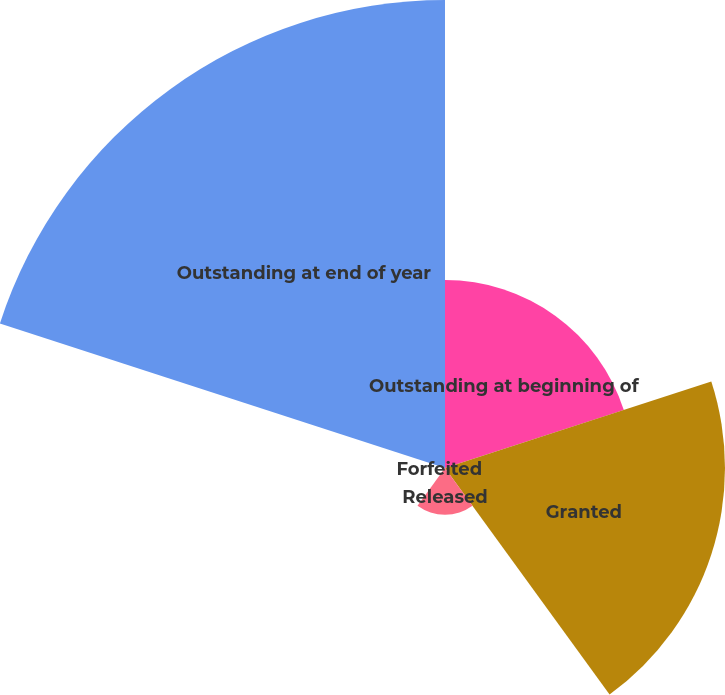Convert chart to OTSL. <chart><loc_0><loc_0><loc_500><loc_500><pie_chart><fcel>Outstanding at beginning of<fcel>Granted<fcel>Released<fcel>Forfeited<fcel>Outstanding at end of year<nl><fcel>19.13%<fcel>28.49%<fcel>4.76%<fcel>0.0%<fcel>47.62%<nl></chart> 